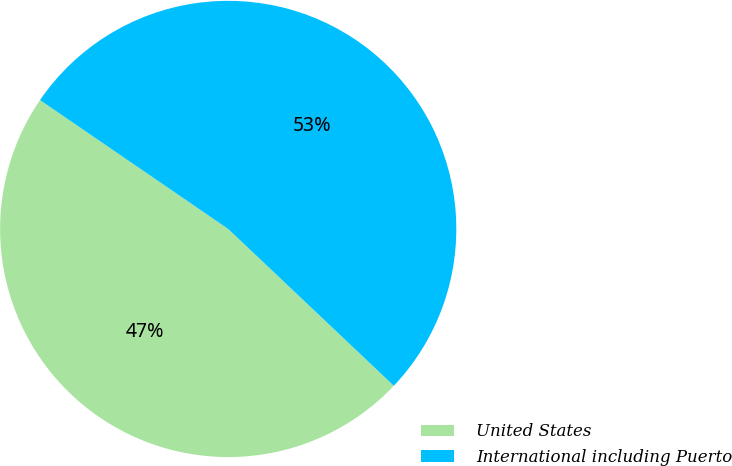Convert chart to OTSL. <chart><loc_0><loc_0><loc_500><loc_500><pie_chart><fcel>United States<fcel>International including Puerto<nl><fcel>47.49%<fcel>52.51%<nl></chart> 